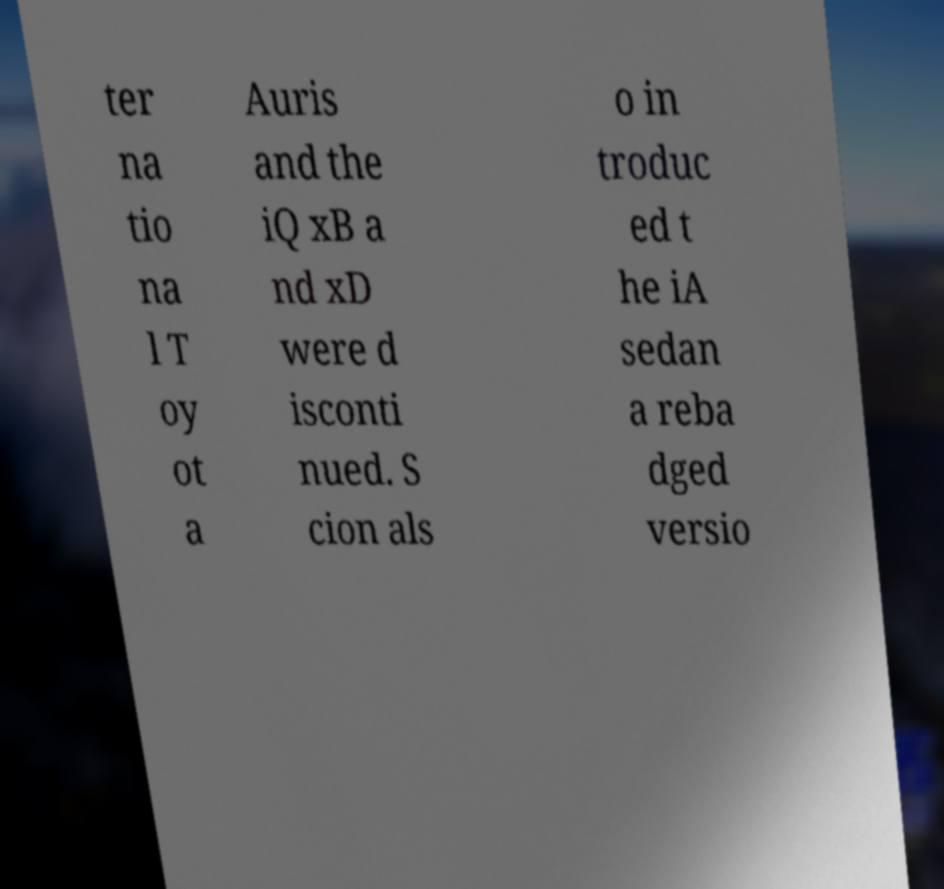What messages or text are displayed in this image? I need them in a readable, typed format. ter na tio na l T oy ot a Auris and the iQ xB a nd xD were d isconti nued. S cion als o in troduc ed t he iA sedan a reba dged versio 